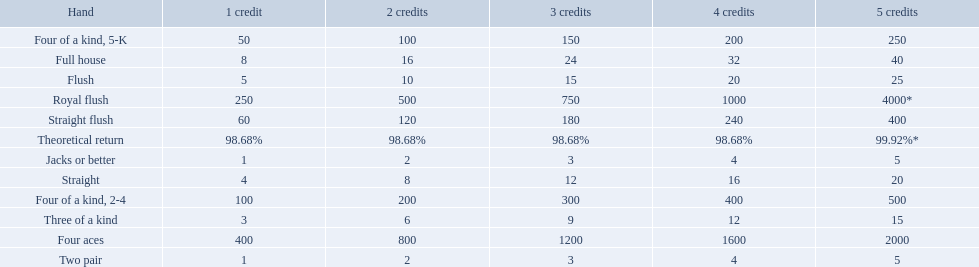Which hand is the third best hand in the card game super aces? Four aces. Which hand is the second best hand? Straight flush. Which hand had is the best hand? Royal flush. 